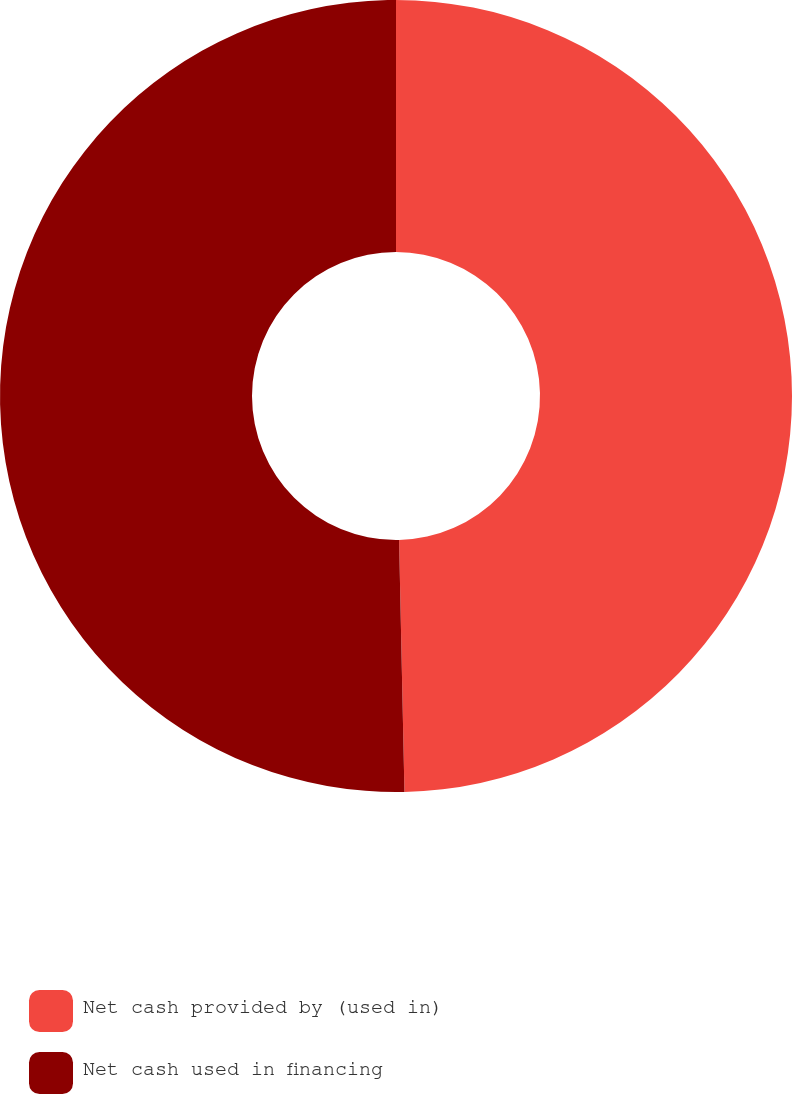<chart> <loc_0><loc_0><loc_500><loc_500><pie_chart><fcel>Net cash provided by (used in)<fcel>Net cash used in financing<nl><fcel>49.66%<fcel>50.34%<nl></chart> 